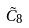<formula> <loc_0><loc_0><loc_500><loc_500>\tilde { C } _ { 8 }</formula> 